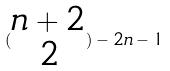<formula> <loc_0><loc_0><loc_500><loc_500>( \begin{matrix} n + 2 \\ 2 \end{matrix} ) - 2 n - 1</formula> 